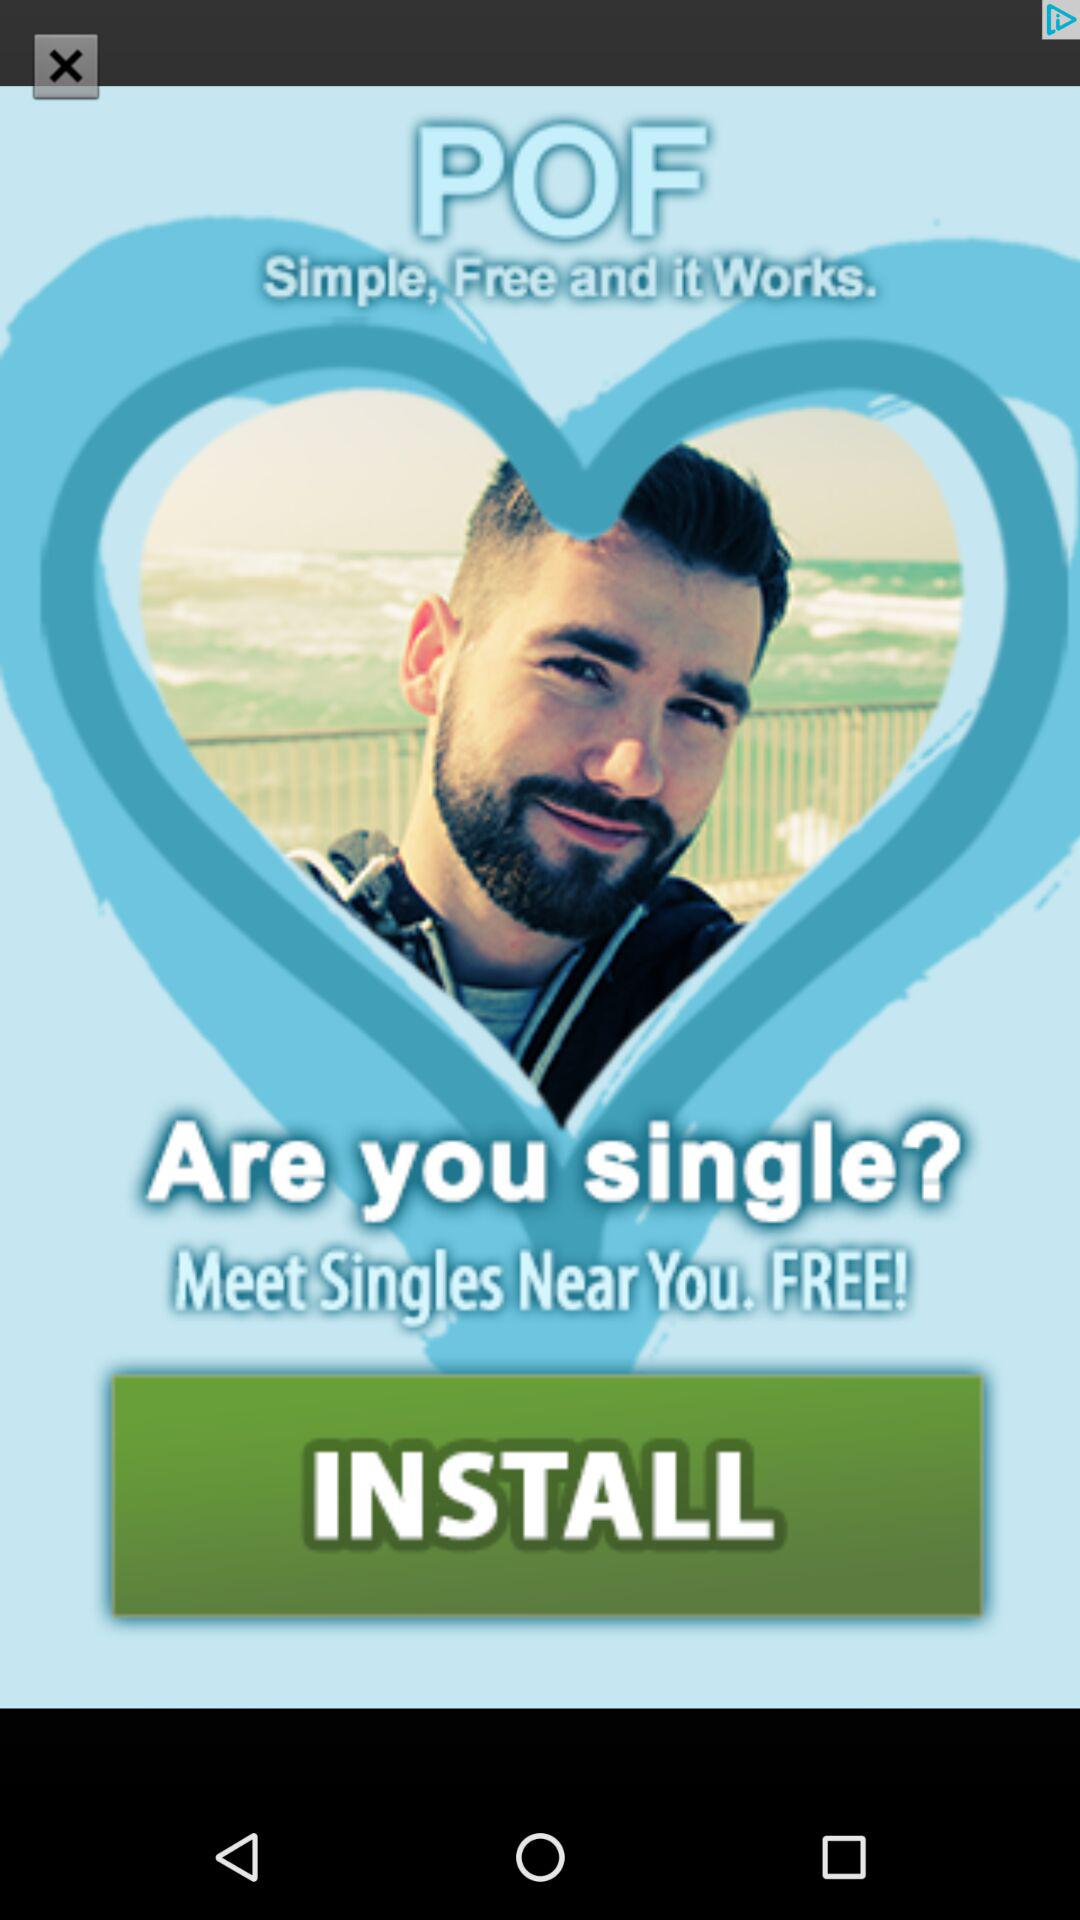What is the application name? The application name is "POF". 